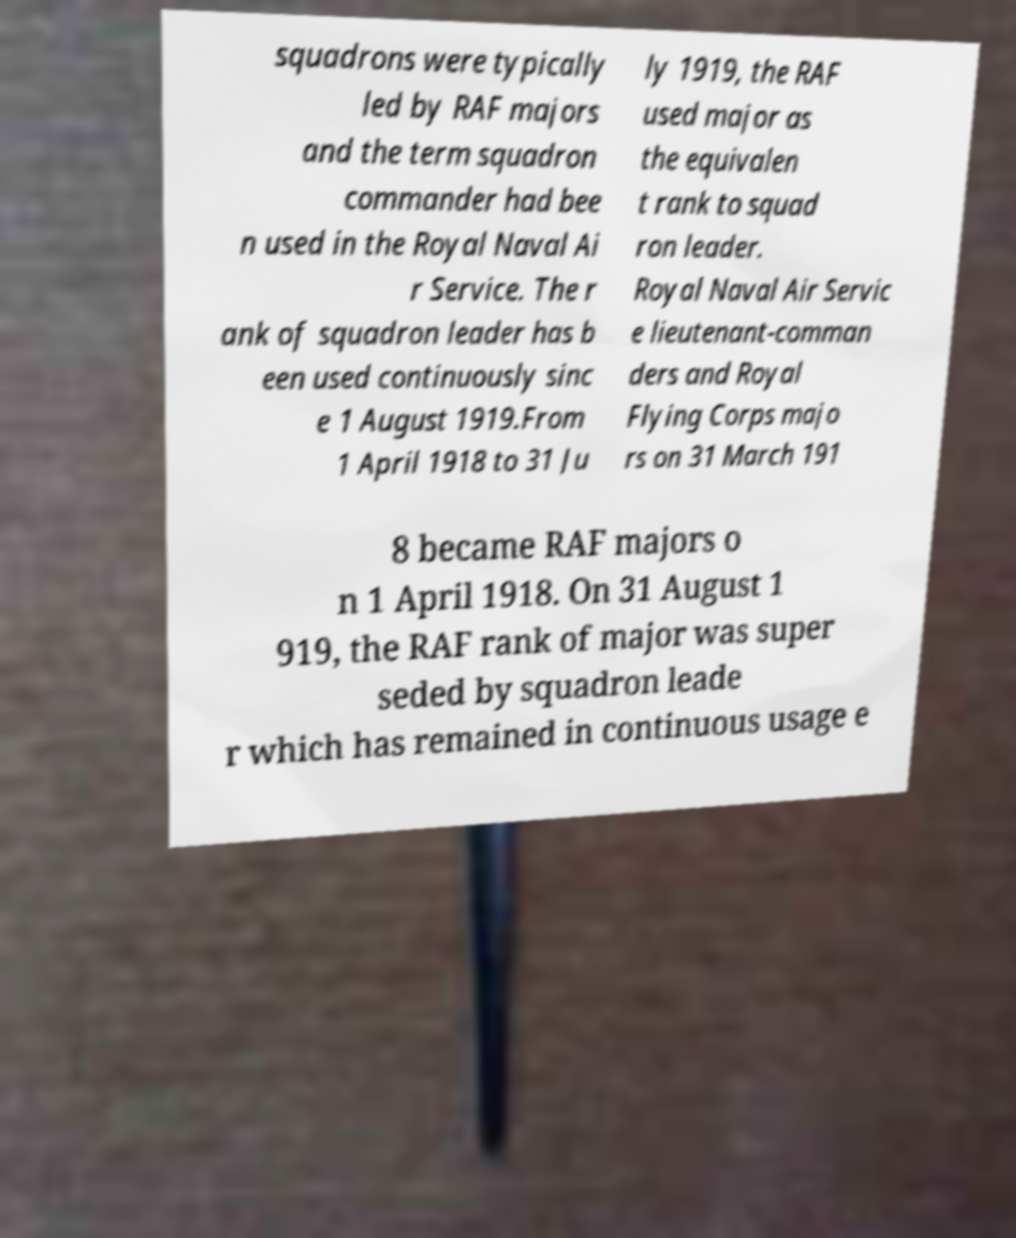Please identify and transcribe the text found in this image. squadrons were typically led by RAF majors and the term squadron commander had bee n used in the Royal Naval Ai r Service. The r ank of squadron leader has b een used continuously sinc e 1 August 1919.From 1 April 1918 to 31 Ju ly 1919, the RAF used major as the equivalen t rank to squad ron leader. Royal Naval Air Servic e lieutenant-comman ders and Royal Flying Corps majo rs on 31 March 191 8 became RAF majors o n 1 April 1918. On 31 August 1 919, the RAF rank of major was super seded by squadron leade r which has remained in continuous usage e 